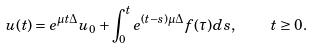Convert formula to latex. <formula><loc_0><loc_0><loc_500><loc_500>u ( t ) = e ^ { \mu t \Delta } u _ { 0 } + \int _ { 0 } ^ { t } e ^ { ( t - s ) \mu \Delta } f ( \tau ) d s , \quad t \geq 0 .</formula> 